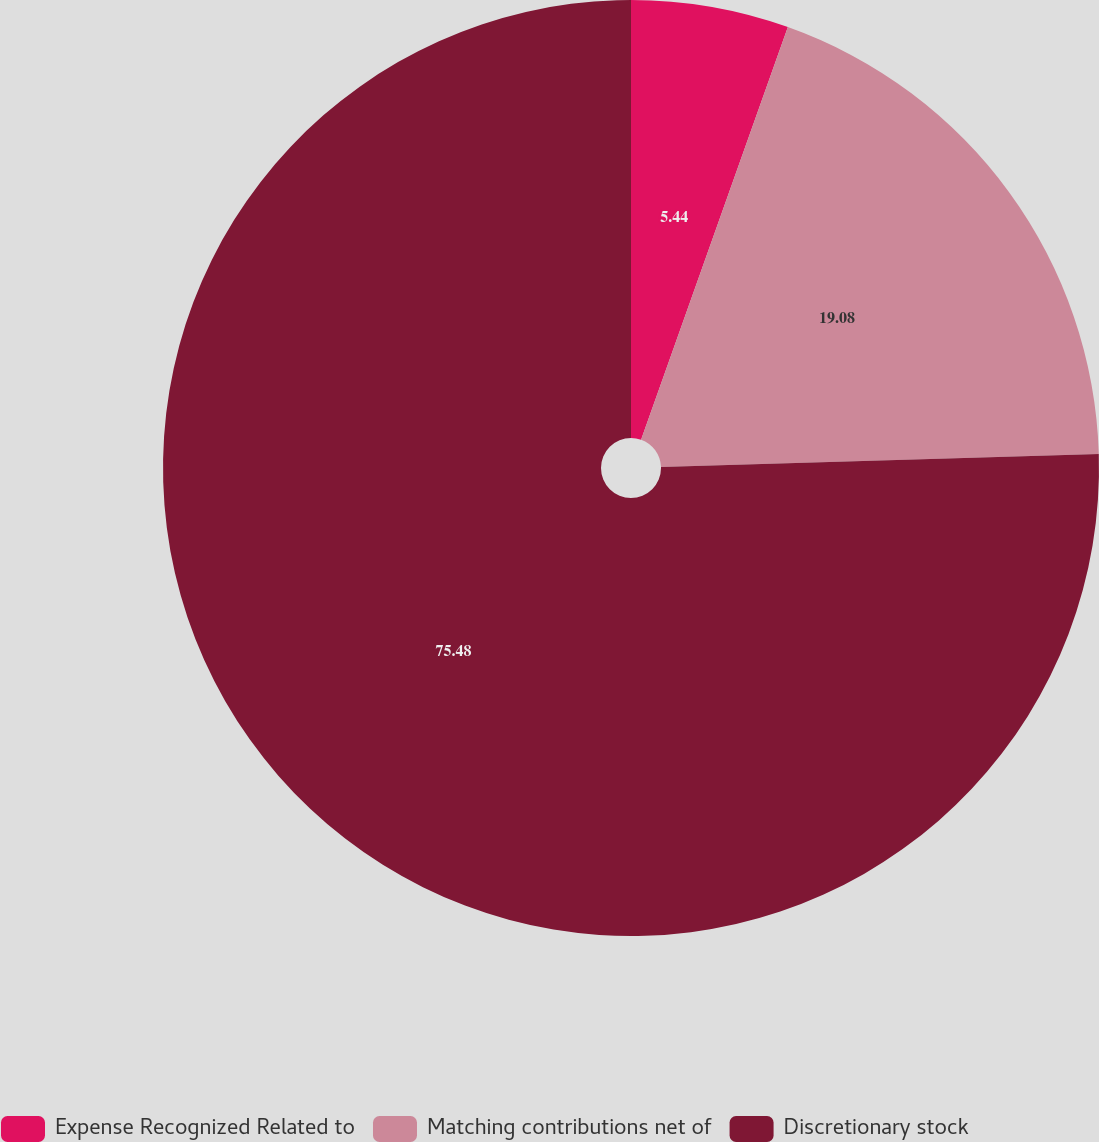Convert chart. <chart><loc_0><loc_0><loc_500><loc_500><pie_chart><fcel>Expense Recognized Related to<fcel>Matching contributions net of<fcel>Discretionary stock<nl><fcel>5.44%<fcel>19.08%<fcel>75.48%<nl></chart> 